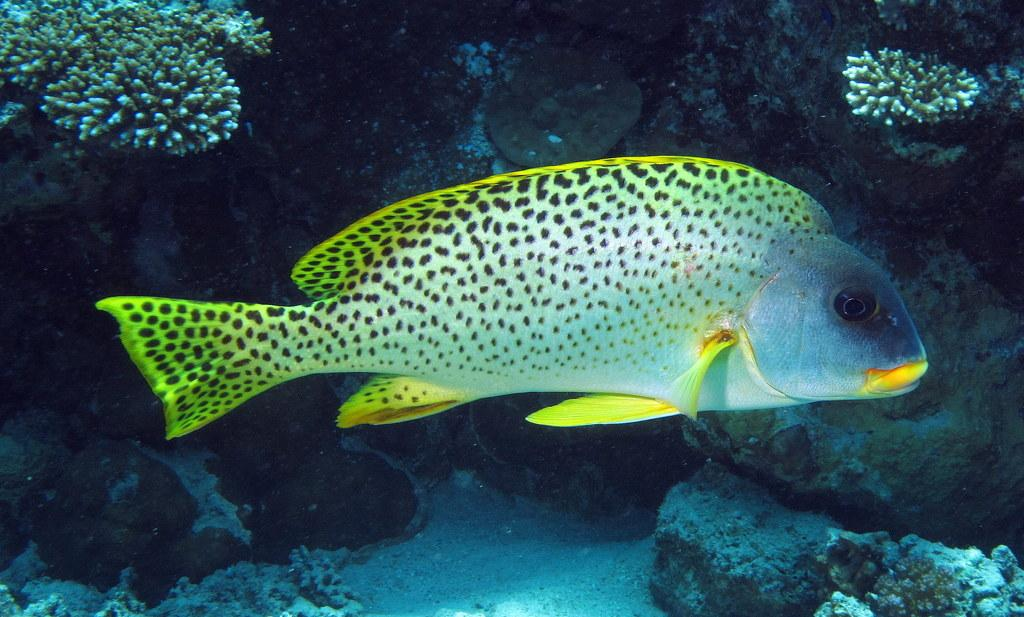What is the main subject in the center of the image? There is a fish in the center of the image. What type of vegetation can be seen in the background of the image? There are sea plants in the background of the image. What other elements are present in the background of the image? Rocks and soil are visible in the background of the image. What is the primary substance surrounding the fish? Water is present in the image. What note is the fish playing on the musical instrument in the image? There is: There is no musical instrument or note present in the image; it features a fish in water with sea plants, rocks, and soil in the background. 